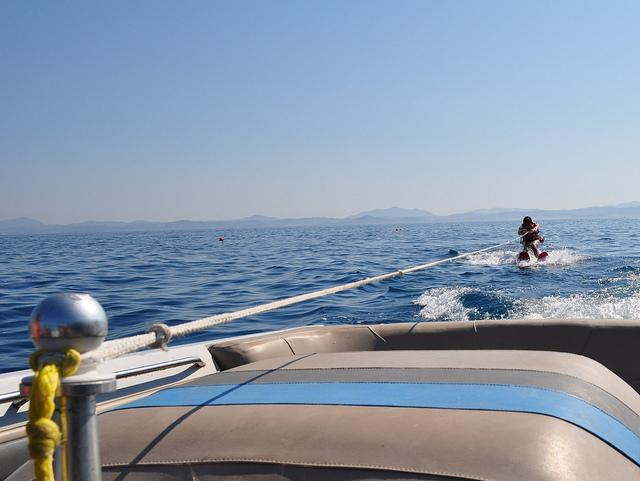Is the boat and skier alone on the water?
Keep it brief. Yes. What is the rope attached to?
Concise answer only. Water skier. Is the water turbulent?
Write a very short answer. No. What is this person doing?
Be succinct. Water skiing. 